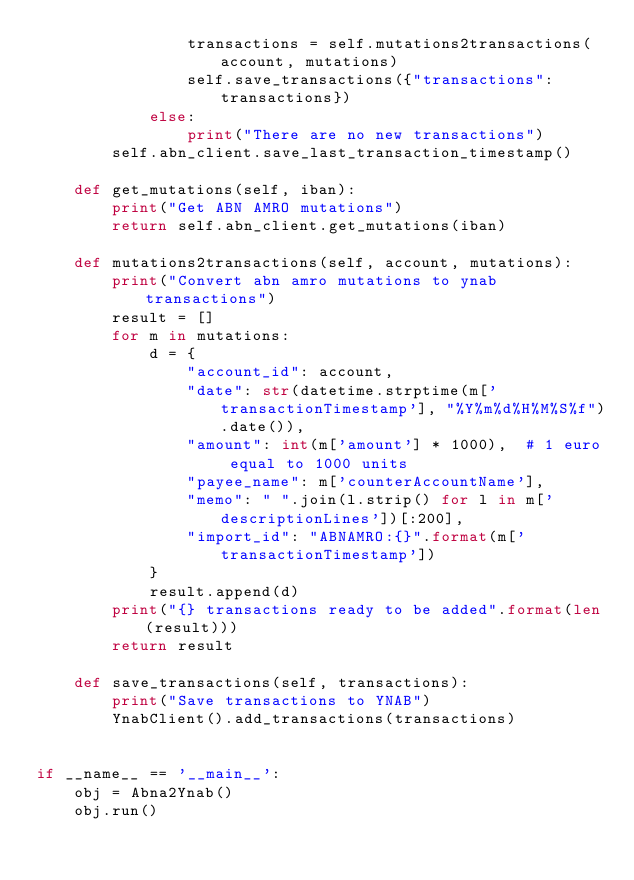Convert code to text. <code><loc_0><loc_0><loc_500><loc_500><_Python_>                transactions = self.mutations2transactions(account, mutations)
                self.save_transactions({"transactions": transactions})
            else:
                print("There are no new transactions")
        self.abn_client.save_last_transaction_timestamp()

    def get_mutations(self, iban):
        print("Get ABN AMRO mutations")
        return self.abn_client.get_mutations(iban)

    def mutations2transactions(self, account, mutations):
        print("Convert abn amro mutations to ynab transactions")
        result = []
        for m in mutations:
            d = {
                "account_id": account,
                "date": str(datetime.strptime(m['transactionTimestamp'], "%Y%m%d%H%M%S%f").date()),
                "amount": int(m['amount'] * 1000),  # 1 euro equal to 1000 units
                "payee_name": m['counterAccountName'],
                "memo": " ".join(l.strip() for l in m['descriptionLines'])[:200],
                "import_id": "ABNAMRO:{}".format(m['transactionTimestamp'])
            }
            result.append(d)
        print("{} transactions ready to be added".format(len(result)))
        return result

    def save_transactions(self, transactions):
        print("Save transactions to YNAB")
        YnabClient().add_transactions(transactions)


if __name__ == '__main__':
    obj = Abna2Ynab()
    obj.run()
</code> 